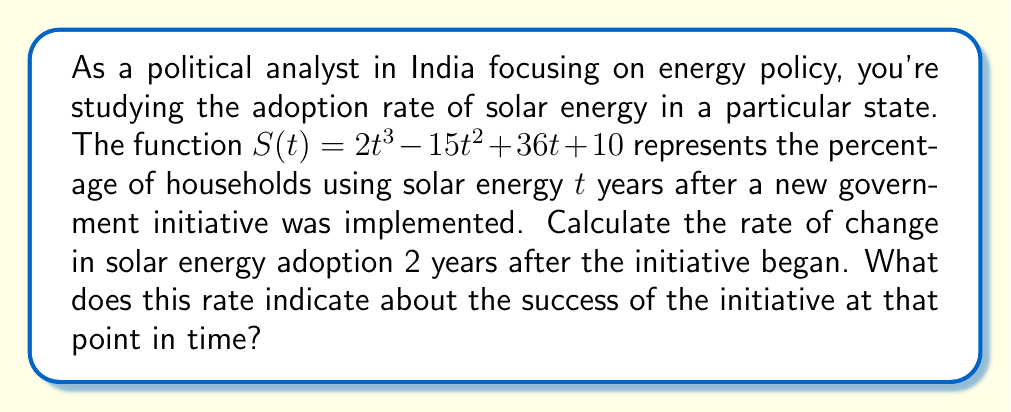Can you solve this math problem? To solve this problem, we need to find the derivative of the given function and evaluate it at $t = 2$. This will give us the instantaneous rate of change in solar energy adoption 2 years after the initiative began.

1. First, let's find the derivative of $S(t)$:

   $S(t) = 2t^3 - 15t^2 + 36t + 10$
   $S'(t) = 6t^2 - 30t + 36$

   This derivative represents the rate of change of solar energy adoption at any given time $t$.

2. Now, we need to evaluate $S'(t)$ at $t = 2$:

   $S'(2) = 6(2)^2 - 30(2) + 36$
   $= 6(4) - 60 + 36$
   $= 24 - 60 + 36$
   $= 0$

3. Interpreting the result:
   The rate of change at $t = 2$ is 0 percentage points per year. This means that 2 years after the initiative began, the adoption rate of solar energy had momentarily plateaued.

   In terms of the initiative's success, this result suggests that:
   a) The initial growth in adoption had slowed down by the second year.
   b) The initiative may need reassessment or additional measures to maintain growth.
   c) This could be a turning point, after which adoption rates might start increasing or decreasing, depending on other factors.

To gain more insight, we could analyze the second derivative to determine if this point is a local maximum or minimum, which would provide additional context for policy recommendations.
Answer: The rate of change in solar energy adoption 2 years after the initiative began is 0 percentage points per year, indicating a momentary plateau in the adoption rate at that time. 